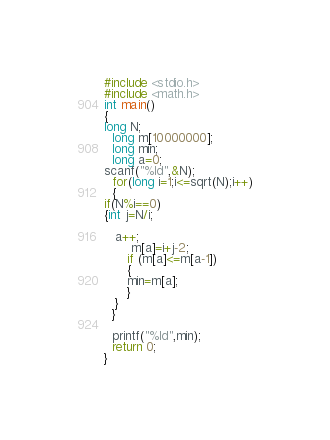<code> <loc_0><loc_0><loc_500><loc_500><_C_>#include <stdio.h>
#include <math.h>
int main()
{
long N;
  long m[10000000];
  long min;
  long a=0;
scanf("%ld",&N);
  for(long i=1;i<=sqrt(N);i++)
  {
if(N%i==0)
{int j=N/i;
   
   a++;
       m[a]=i+j-2;
      if (m[a]<=m[a-1])
      {
      min=m[a];
      }
   }
  }
  
  printf("%ld",min);
  return 0;
}
</code> 